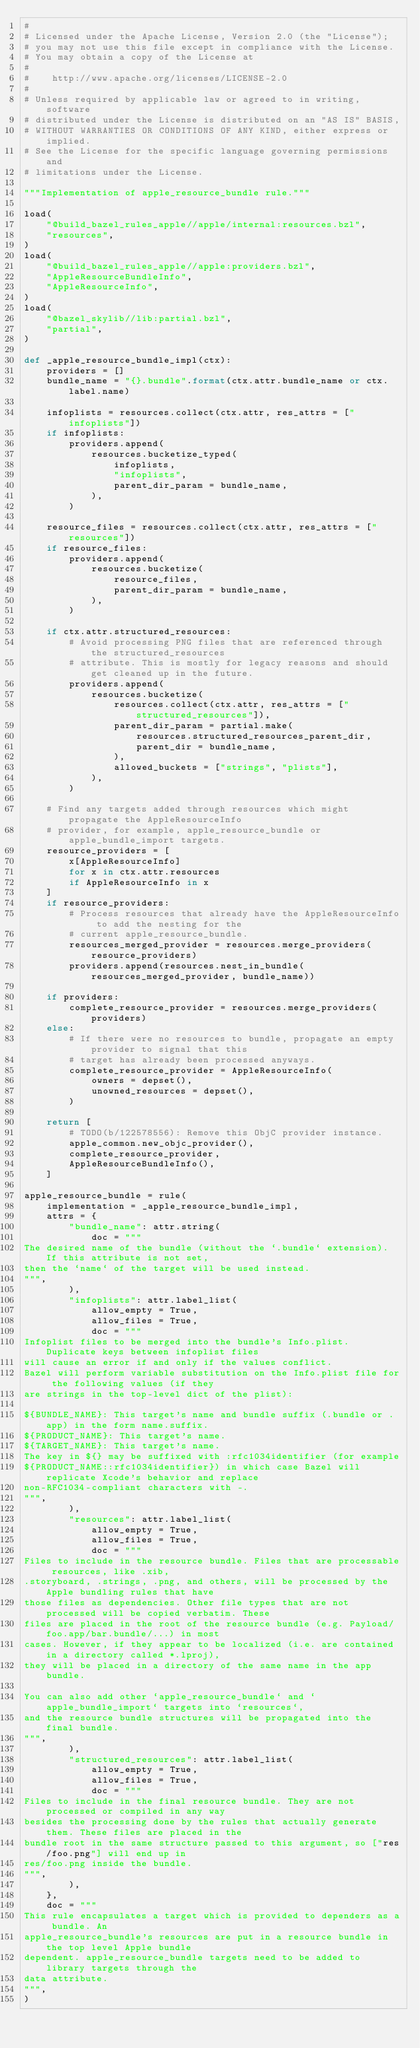<code> <loc_0><loc_0><loc_500><loc_500><_Python_>#
# Licensed under the Apache License, Version 2.0 (the "License");
# you may not use this file except in compliance with the License.
# You may obtain a copy of the License at
#
#    http://www.apache.org/licenses/LICENSE-2.0
#
# Unless required by applicable law or agreed to in writing, software
# distributed under the License is distributed on an "AS IS" BASIS,
# WITHOUT WARRANTIES OR CONDITIONS OF ANY KIND, either express or implied.
# See the License for the specific language governing permissions and
# limitations under the License.

"""Implementation of apple_resource_bundle rule."""

load(
    "@build_bazel_rules_apple//apple/internal:resources.bzl",
    "resources",
)
load(
    "@build_bazel_rules_apple//apple:providers.bzl",
    "AppleResourceBundleInfo",
    "AppleResourceInfo",
)
load(
    "@bazel_skylib//lib:partial.bzl",
    "partial",
)

def _apple_resource_bundle_impl(ctx):
    providers = []
    bundle_name = "{}.bundle".format(ctx.attr.bundle_name or ctx.label.name)

    infoplists = resources.collect(ctx.attr, res_attrs = ["infoplists"])
    if infoplists:
        providers.append(
            resources.bucketize_typed(
                infoplists,
                "infoplists",
                parent_dir_param = bundle_name,
            ),
        )

    resource_files = resources.collect(ctx.attr, res_attrs = ["resources"])
    if resource_files:
        providers.append(
            resources.bucketize(
                resource_files,
                parent_dir_param = bundle_name,
            ),
        )

    if ctx.attr.structured_resources:
        # Avoid processing PNG files that are referenced through the structured_resources
        # attribute. This is mostly for legacy reasons and should get cleaned up in the future.
        providers.append(
            resources.bucketize(
                resources.collect(ctx.attr, res_attrs = ["structured_resources"]),
                parent_dir_param = partial.make(
                    resources.structured_resources_parent_dir,
                    parent_dir = bundle_name,
                ),
                allowed_buckets = ["strings", "plists"],
            ),
        )

    # Find any targets added through resources which might propagate the AppleResourceInfo
    # provider, for example, apple_resource_bundle or apple_bundle_import targets.
    resource_providers = [
        x[AppleResourceInfo]
        for x in ctx.attr.resources
        if AppleResourceInfo in x
    ]
    if resource_providers:
        # Process resources that already have the AppleResourceInfo to add the nesting for the
        # current apple_resource_bundle.
        resources_merged_provider = resources.merge_providers(resource_providers)
        providers.append(resources.nest_in_bundle(resources_merged_provider, bundle_name))

    if providers:
        complete_resource_provider = resources.merge_providers(providers)
    else:
        # If there were no resources to bundle, propagate an empty provider to signal that this
        # target has already been processed anyways.
        complete_resource_provider = AppleResourceInfo(
            owners = depset(),
            unowned_resources = depset(),
        )

    return [
        # TODO(b/122578556): Remove this ObjC provider instance.
        apple_common.new_objc_provider(),
        complete_resource_provider,
        AppleResourceBundleInfo(),
    ]

apple_resource_bundle = rule(
    implementation = _apple_resource_bundle_impl,
    attrs = {
        "bundle_name": attr.string(
            doc = """
The desired name of the bundle (without the `.bundle` extension). If this attribute is not set,
then the `name` of the target will be used instead.
""",
        ),
        "infoplists": attr.label_list(
            allow_empty = True,
            allow_files = True,
            doc = """
Infoplist files to be merged into the bundle's Info.plist. Duplicate keys between infoplist files
will cause an error if and only if the values conflict.
Bazel will perform variable substitution on the Info.plist file for the following values (if they
are strings in the top-level dict of the plist):

${BUNDLE_NAME}: This target's name and bundle suffix (.bundle or .app) in the form name.suffix.
${PRODUCT_NAME}: This target's name.
${TARGET_NAME}: This target's name.
The key in ${} may be suffixed with :rfc1034identifier (for example
${PRODUCT_NAME::rfc1034identifier}) in which case Bazel will replicate Xcode's behavior and replace
non-RFC1034-compliant characters with -.
""",
        ),
        "resources": attr.label_list(
            allow_empty = True,
            allow_files = True,
            doc = """
Files to include in the resource bundle. Files that are processable resources, like .xib,
.storyboard, .strings, .png, and others, will be processed by the Apple bundling rules that have
those files as dependencies. Other file types that are not processed will be copied verbatim. These
files are placed in the root of the resource bundle (e.g. Payload/foo.app/bar.bundle/...) in most
cases. However, if they appear to be localized (i.e. are contained in a directory called *.lproj),
they will be placed in a directory of the same name in the app bundle.

You can also add other `apple_resource_bundle` and `apple_bundle_import` targets into `resources`,
and the resource bundle structures will be propagated into the final bundle.
""",
        ),
        "structured_resources": attr.label_list(
            allow_empty = True,
            allow_files = True,
            doc = """
Files to include in the final resource bundle. They are not processed or compiled in any way
besides the processing done by the rules that actually generate them. These files are placed in the
bundle root in the same structure passed to this argument, so ["res/foo.png"] will end up in
res/foo.png inside the bundle.
""",
        ),
    },
    doc = """
This rule encapsulates a target which is provided to dependers as a bundle. An
apple_resource_bundle's resources are put in a resource bundle in the top level Apple bundle
dependent. apple_resource_bundle targets need to be added to library targets through the
data attribute.
""",
)
</code> 